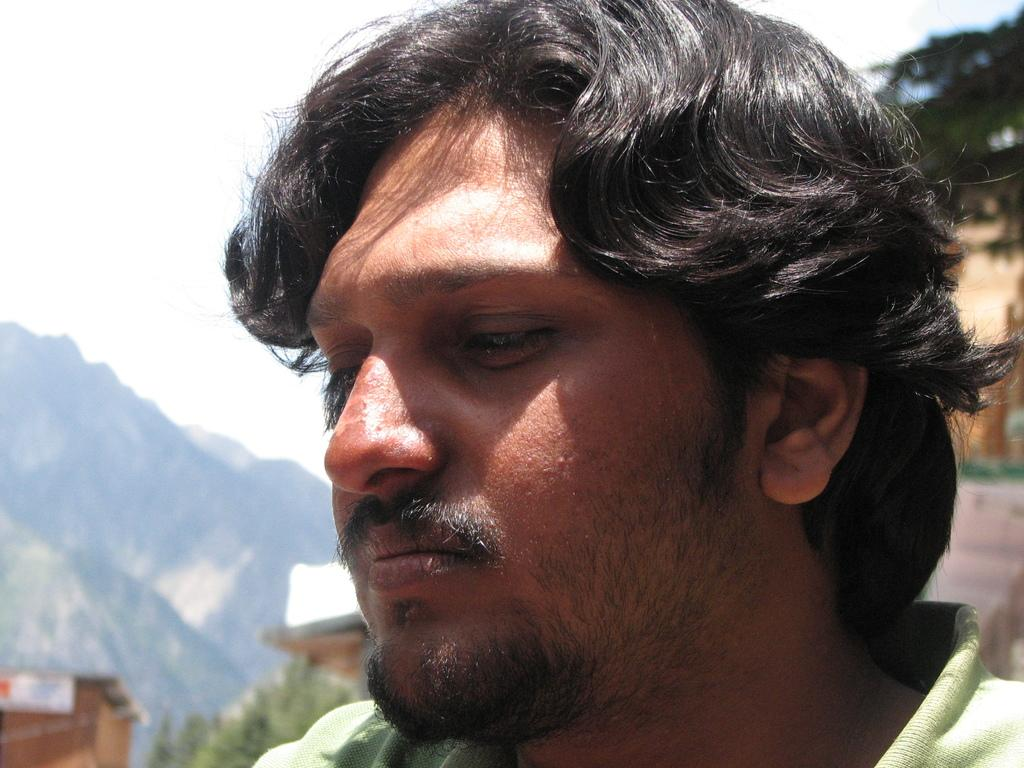Who is present in the image? There is a man in the picture. What can be observed about the background of the image? The background of the image is blurry. What type of natural features are visible in the background? There are trees and hills in the background of the image. What part of the natural environment is visible in the image? The sky is visible in the background of the image. What type of clam is being used as a hat by the man in the image? There is no clam present in the image, and the man is not wearing a hat. What is the man's state of mind in the image? The image does not provide any information about the man's state of mind. 